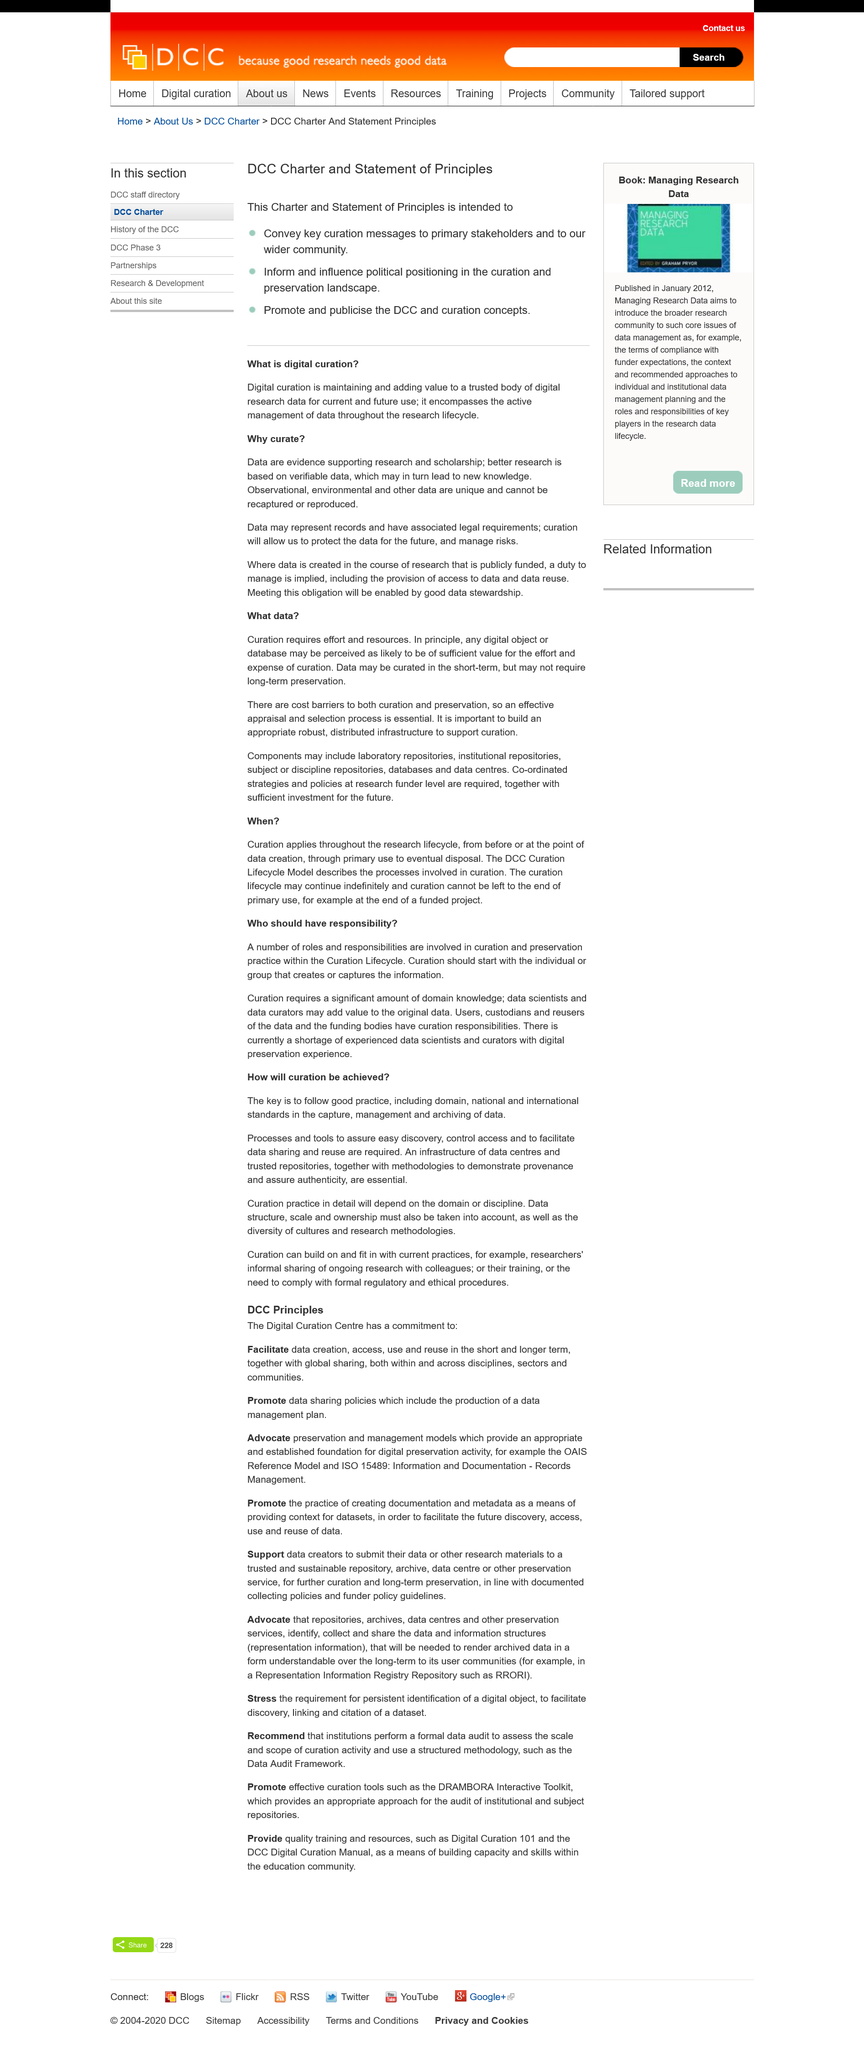Point out several critical features in this image. Records and data may be represented and may be subject to legal requirements. Better research is based on verifiable data. It is important to curate data even if some of it is unique, as the unique nature of the data is a compelling reason to do so. 